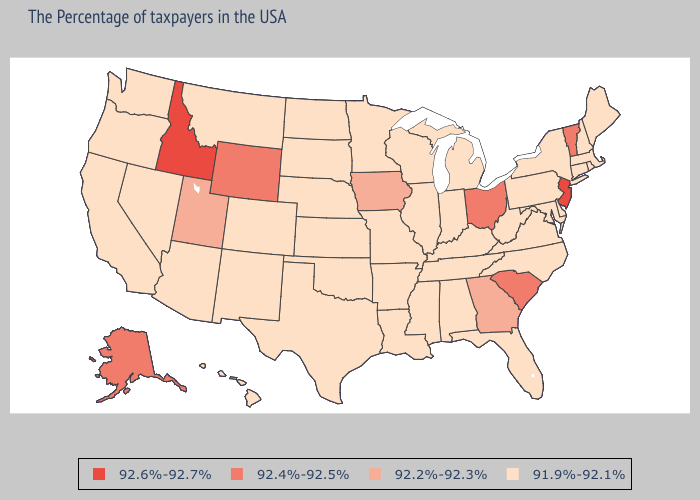What is the lowest value in states that border Maine?
Short answer required. 91.9%-92.1%. Name the states that have a value in the range 92.4%-92.5%?
Keep it brief. Vermont, South Carolina, Ohio, Wyoming, Alaska. Is the legend a continuous bar?
Keep it brief. No. Name the states that have a value in the range 92.6%-92.7%?
Write a very short answer. New Jersey, Idaho. Does Kentucky have the lowest value in the South?
Give a very brief answer. Yes. Name the states that have a value in the range 92.6%-92.7%?
Concise answer only. New Jersey, Idaho. What is the highest value in the Northeast ?
Write a very short answer. 92.6%-92.7%. What is the value of Maine?
Give a very brief answer. 91.9%-92.1%. Does Maryland have the lowest value in the USA?
Concise answer only. Yes. Does Idaho have the highest value in the West?
Concise answer only. Yes. What is the value of Massachusetts?
Answer briefly. 91.9%-92.1%. What is the value of California?
Quick response, please. 91.9%-92.1%. What is the value of North Carolina?
Short answer required. 91.9%-92.1%. Does Wisconsin have the same value as Idaho?
Be succinct. No. Among the states that border Oregon , which have the lowest value?
Quick response, please. Nevada, California, Washington. 